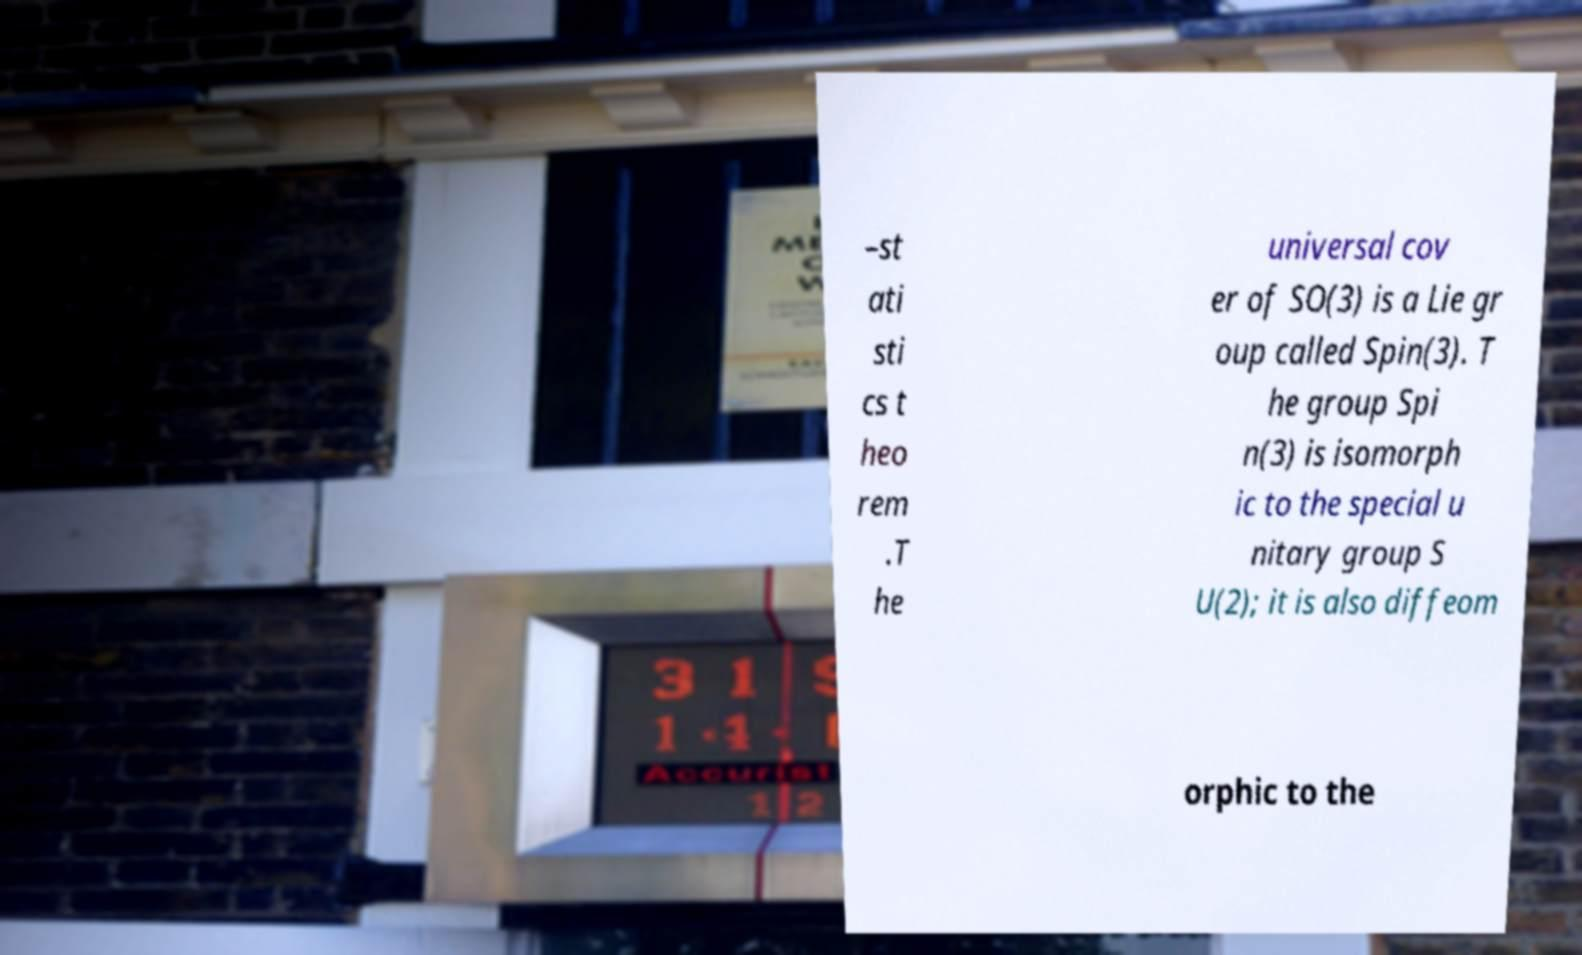Can you read and provide the text displayed in the image?This photo seems to have some interesting text. Can you extract and type it out for me? –st ati sti cs t heo rem .T he universal cov er of SO(3) is a Lie gr oup called Spin(3). T he group Spi n(3) is isomorph ic to the special u nitary group S U(2); it is also diffeom orphic to the 